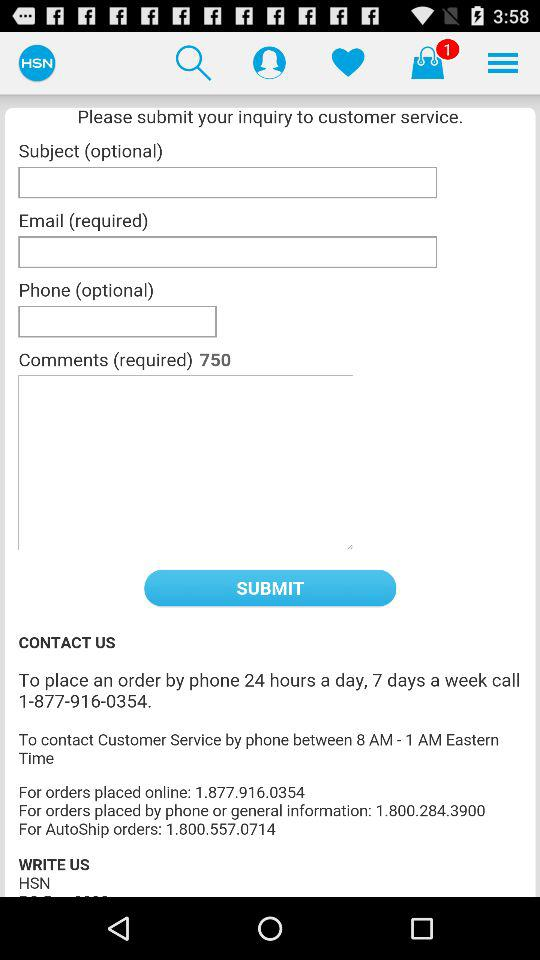How many items are in the bag? There is 1 item in the bag. 